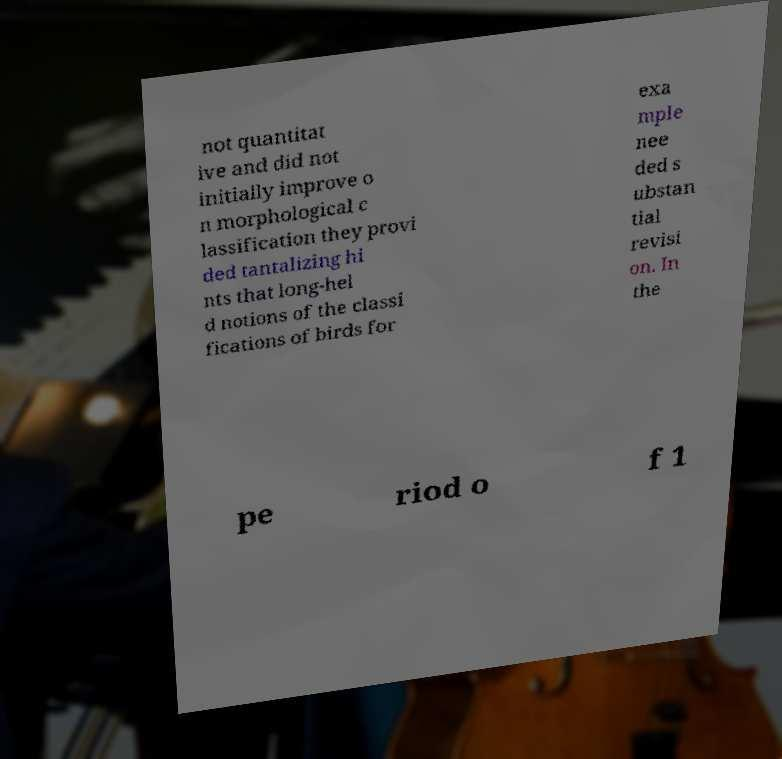There's text embedded in this image that I need extracted. Can you transcribe it verbatim? not quantitat ive and did not initially improve o n morphological c lassification they provi ded tantalizing hi nts that long-hel d notions of the classi fications of birds for exa mple nee ded s ubstan tial revisi on. In the pe riod o f 1 